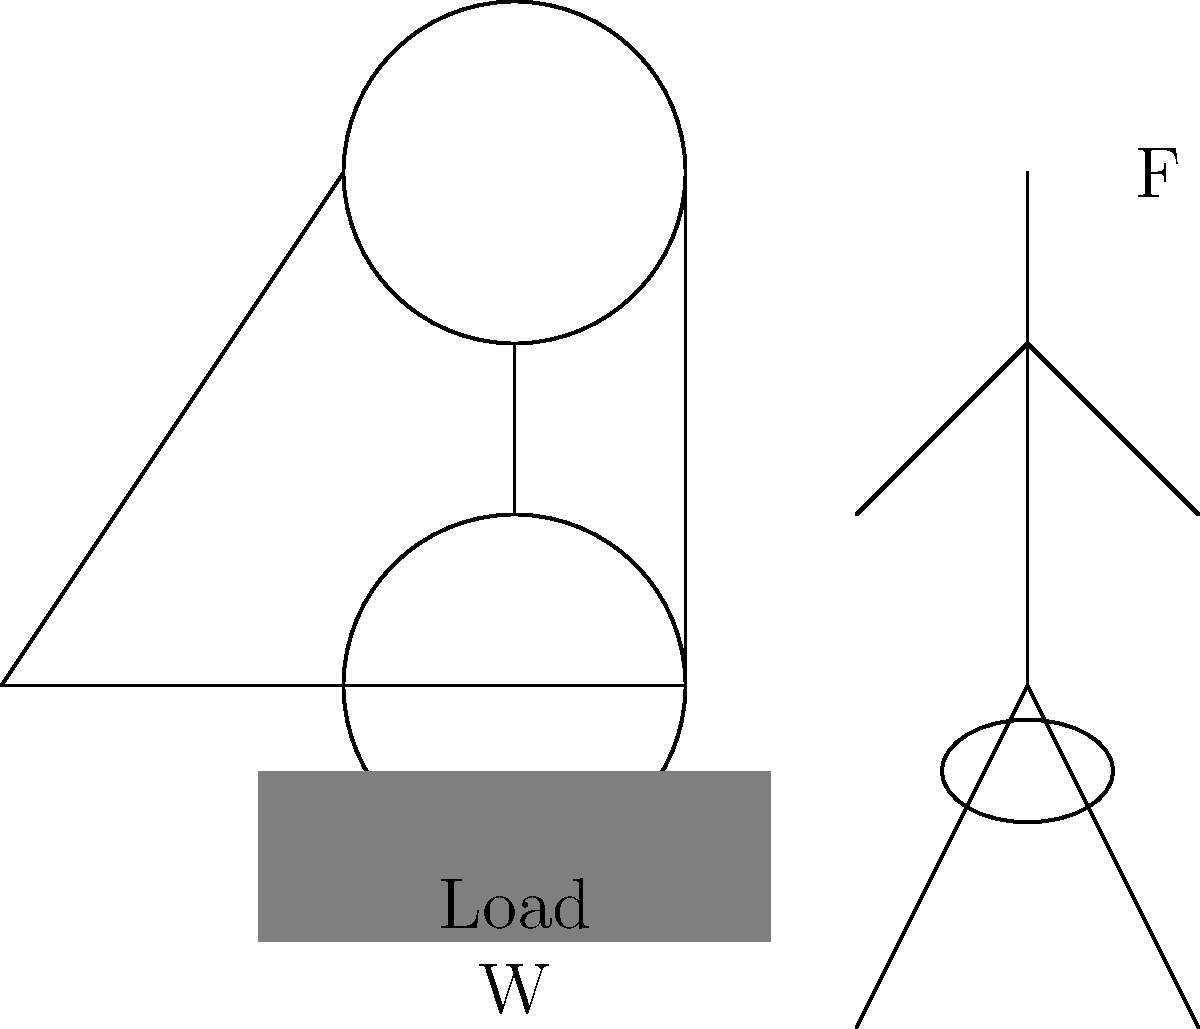You're preparing for a family camping trip in the scenic outdoors of Oregon. To make it easier to lift your heavy camping gear, you decide to use a simple pulley system. The system consists of two pulleys as shown in the diagram. If the weight of your camping gear is 200 lbs, what force $F$ (in lbs) do you need to apply to lift the gear, assuming the pulleys are frictionless and the ropes are massless? To solve this problem, we'll follow these steps:

1) In a simple pulley system, the mechanical advantage (MA) is equal to the number of rope segments supporting the load.

2) In this system, there are two rope segments supporting the load (one on each side of the lower pulley).

3) The mechanical advantage is therefore:
   $MA = 2$

4) The mechanical advantage is defined as the ratio of the load to the effort:
   $MA = \frac{Load}{Effort} = \frac{W}{F}$

5) We can rearrange this equation to solve for the effort (F):
   $F = \frac{W}{MA}$

6) Substituting the values:
   $F = \frac{200 \text{ lbs}}{2} = 100 \text{ lbs}$

Therefore, you need to apply a force of 100 lbs to lift the 200 lb camping gear using this pulley system.
Answer: 100 lbs 